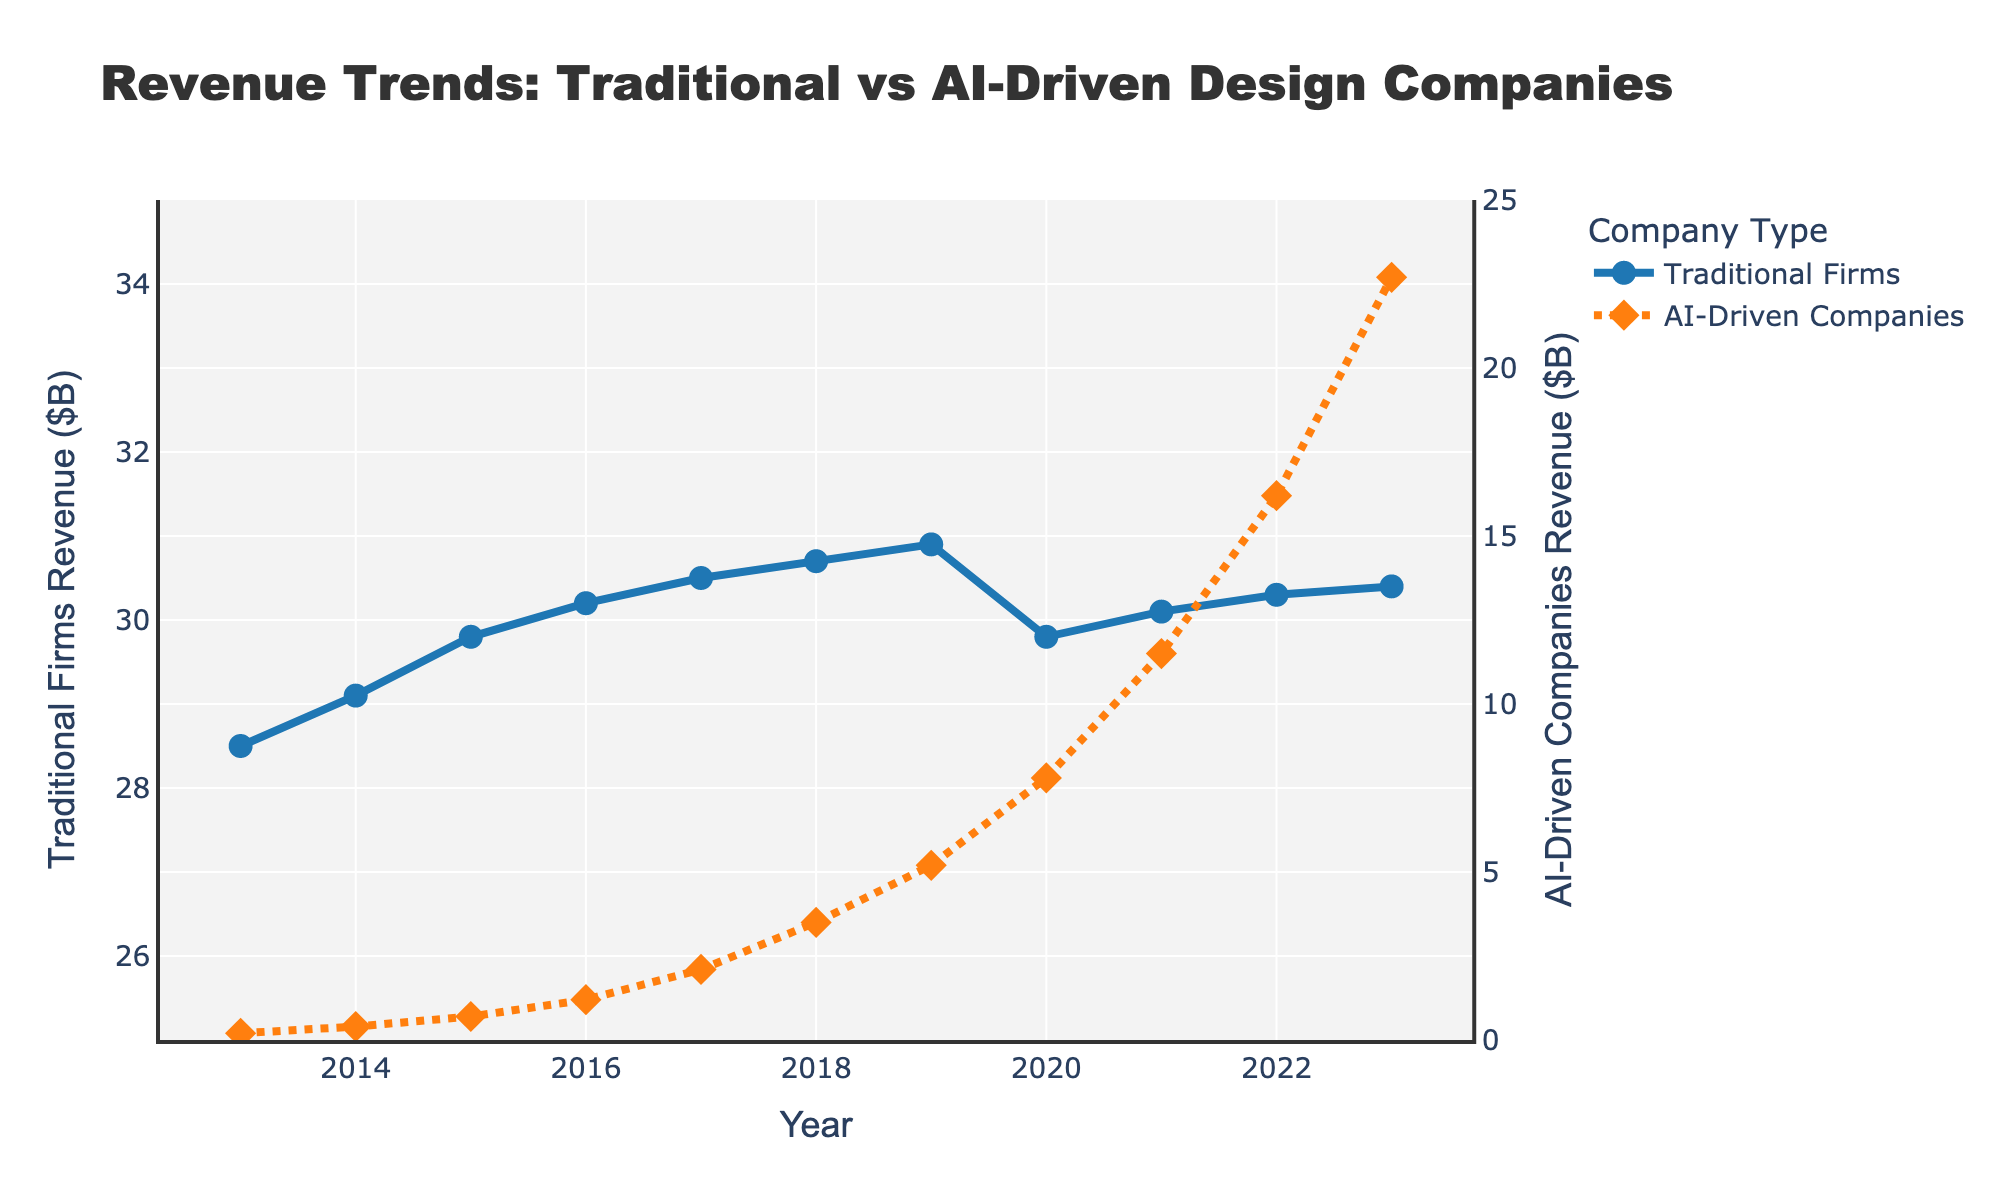What is the revenue difference between Traditional Graphic Design Firms and AI-Driven Design Companies in 2013? In 2013, the revenue for Traditional Graphic Design Firms is $28.5B and for AI-Driven Design Companies is $0.2B. The difference is $28.5B - $0.2B
Answer: $28.3B What is the trend of revenue for Traditional Graphic Design Firms from 2020 to 2023? The revenue for Traditional Graphic Design Firms decreased from $30.9B in 2019 to $29.8B in 2020, then increased to $30.1B in 2021, $30.3B in 2022, and $30.4B in 2023. The overall trend is a slight increase with a dip in 2020
Answer: Slight increase In which year did AI-Driven Design Companies surpass $10B in revenue, and what was their revenue that year? AI-Driven Design Companies surpassed $10B in revenue in 2021, with a revenue of $11.5B
Answer: 2021, $11.5B By how much did the revenue of AI-Driven Design Companies grow from 2013 to 2023? AI-Driven Design Companies' revenue grew from $0.2B in 2013 to $22.7B in 2023. The growth is $22.7B - $0.2B
Answer: $22.5B Which year shows the largest year-over-year revenue increase for AI-Driven Design Companies? The year-over-year revenue increases can be calculated: 0.4-0.2 (2014), 0.7-0.4 (2015), 1.2-0.7 (2016), 2.1-1.2 (2017), 3.5-2.1 (2018), 5.2-3.5 (2019), 7.8-5.2 (2020), 11.5-7.8 (2021), 16.2-11.5 (2022), 22.7-16.2 (2023). The largest increase is from 2022 to 2023, $22.7B - $16.2B
Answer: 2023 What is the average revenue for Traditional Graphic Design Firms over the entire decade? The revenues for Traditional Graphic Design Firms are: 28.5, 29.1, 29.8, 30.2, 30.5, 30.7, 30.9, 29.8, 30.1, 30.3, 30.4. Summing these gives 330.3 and there are 11 data points, so the average is 330.3/11
Answer: $30.027B How do the revenue trends of Traditional Graphic Design Firms and AI-Driven Design Companies visually differ in the graph? Traditional Graphic Design Firms show a stable trend with minor fluctuations and a slight dip in 2020. AI-Driven Design Companies have a steep upward trend, showing rapid growth and significant increases each year, represented by a dotted line.
Answer: Stable vs. Rapid Growth What was the revenue for Traditional Graphic Design Firms during their dip in 2020? According to the trend, the revenue for Traditional Graphic Design Firms in 2020 was $29.8B, which represents a dip compared to other years
Answer: $29.8B How much did the revenue of AI-Driven Design Companies increase from 2019 to 2020, and what is the percentage increase? The revenue for AI-Driven Design Companies increased from $5.2B in 2019 to $7.8B in 2020. The increase is $7.8B - $5.2B = $2.6B. The percentage increase is ($2.6B / $5.2B) * 100
Answer: 50% 